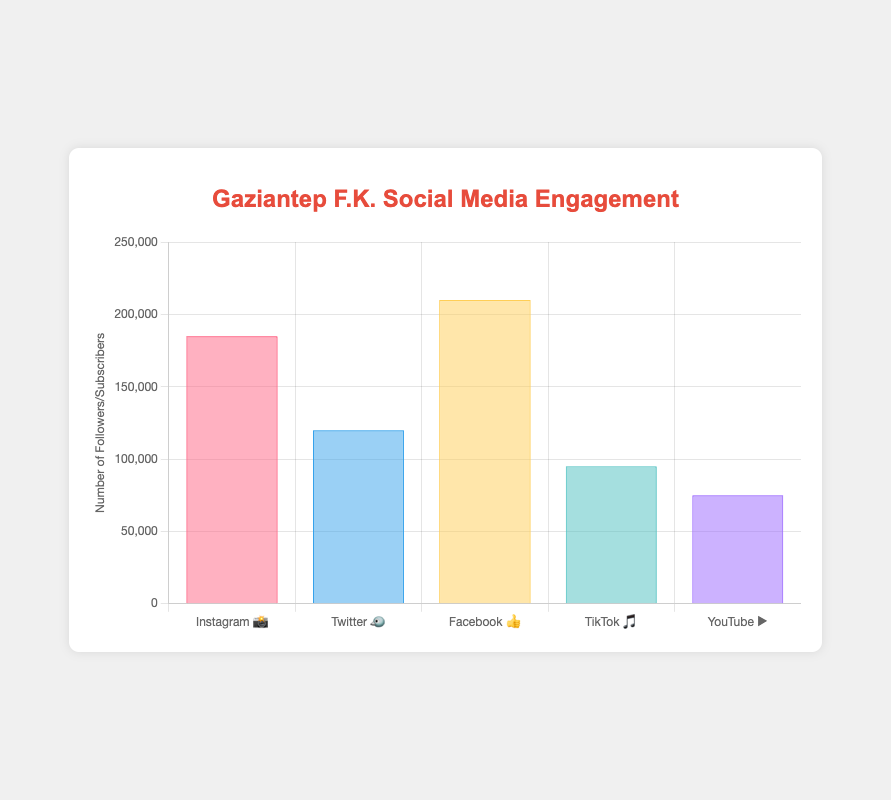Which platform has the most followers? Referring to the bar height labeled with social media platform emojis, Facebook (👍) has the tallest bar indicating the highest follower count of 210,000.
Answer: Facebook 👍 Which platform has the fewest followers? Observing the shortest bar on the chart, TikTok (🎵) has the smallest bar representing the lowest follower count of 95,000.
Answer: TikTok 🎵 How many more followers does Instagram have compared to YouTube? Instagram (📸) has 185,000 followers, and YouTube (▶️) has 75,000. The difference is 185,000 - 75,000 = 110,000.
Answer: 110,000 What's the total number of followers across all platforms? Add the followers from each platform: 185,000 (📸) + 120,000 (🐦) + 210,000 (👍) + 95,000 (🎵) + 75,000 (▶️) = 685,000.
Answer: 685,000 Which two platforms have follower counts closest to each other? Comparing the follower counts: Instagram (185,000) and Facebook (210,000) differ by 25,000, Twitter (120,000) and YouTube (75,000) differ by 45,000, and TikTok (95,000) and YouTube (75,000) differ by 20,000. The closest counts are TikTok and YouTube with a difference of 20,000.
Answer: TikTok 🎵 and YouTube ▶️ What percentage of the total followers come from Instagram? Instagram has 185,000 followers out of a total of 685,000. The percentage is (185,000 / 685,000) * 100 ≈ 27%.
Answer: 27% How does the follower count of Twitter compare to Instagram and Facebook combined? Instagram (185,000) and Facebook (210,000) combined have 395,000 followers. Twitter has 120,000 followers, which is less than the combined follower count of 395,000.
Answer: Less than Instagram and Facebook combined Is the average number of followers greater on Twitter or TikTok? Twitter has 120,000 followers and TikTok has 95,000. 120,000 is greater than 95,000, so Twitter has a higher average number of followers.
Answer: Twitter 🐦 By how much does Facebook’s follower count exceed the average follower count of all platforms? The average follower count is 685,000 / 5 = 137,000. Facebook has 210,000 followers, so 210,000 - 137,000 = 73,000.
Answer: 73,000 What’s the difference between the number of YouTube subscribers and TikTok followers? YouTube has 75,000 subscribers, and TikTok has 95,000 followers. The difference is 95,000 - 75,000 = 20,000.
Answer: 20,000 